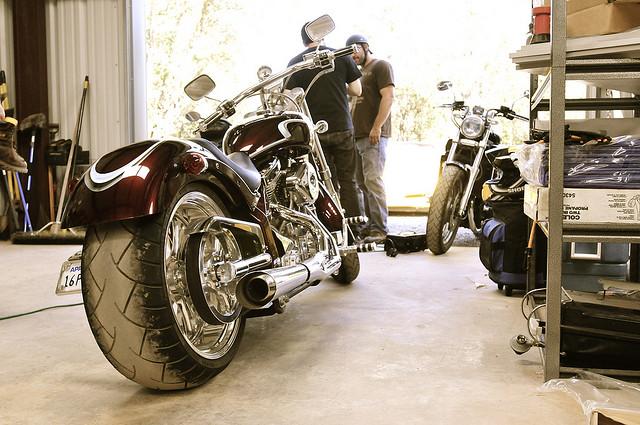How many people are in front of the motorcycle?
Concise answer only. 2. Are they in a garage?
Answer briefly. Yes. Where is the number 6?
Answer briefly. License plate. 